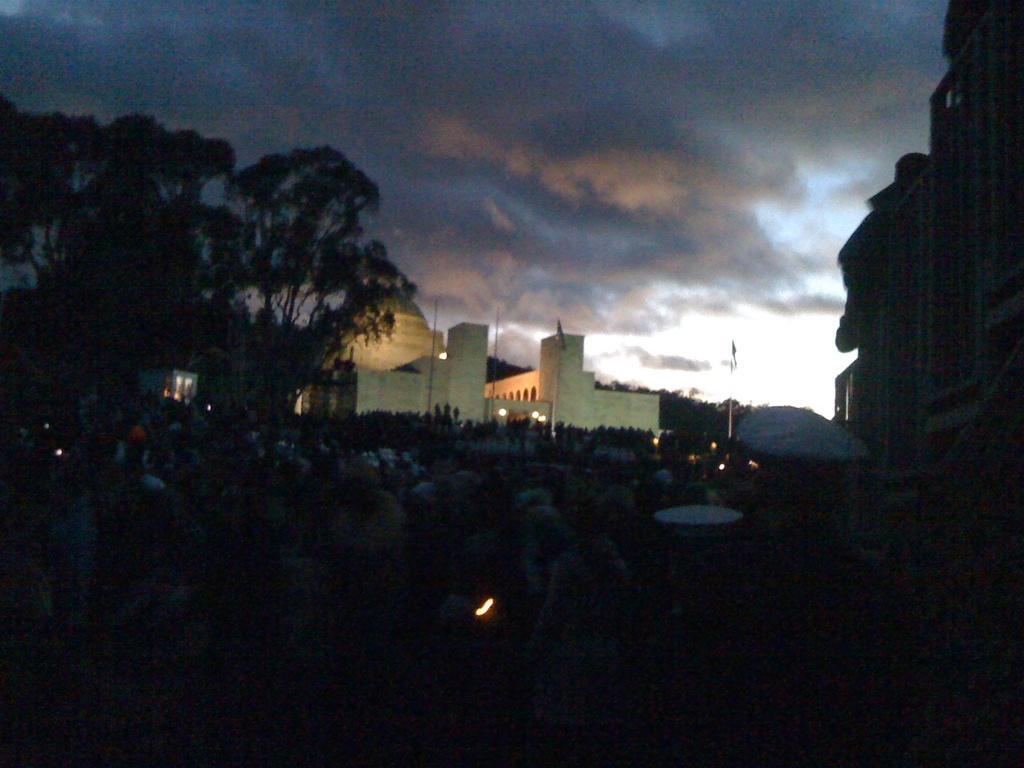Please provide a concise description of this image. These are the buildings. I can see the trees. These look like the flags, which are hanging to the poles. I can see few people standing. These are the clouds in the sky. 